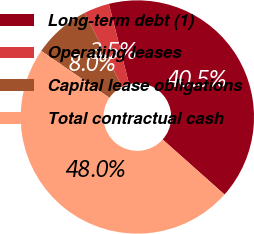<chart> <loc_0><loc_0><loc_500><loc_500><pie_chart><fcel>Long-term debt (1)<fcel>Operating leases<fcel>Capital lease obligations<fcel>Total contractual cash<nl><fcel>40.5%<fcel>3.52%<fcel>7.97%<fcel>48.02%<nl></chart> 